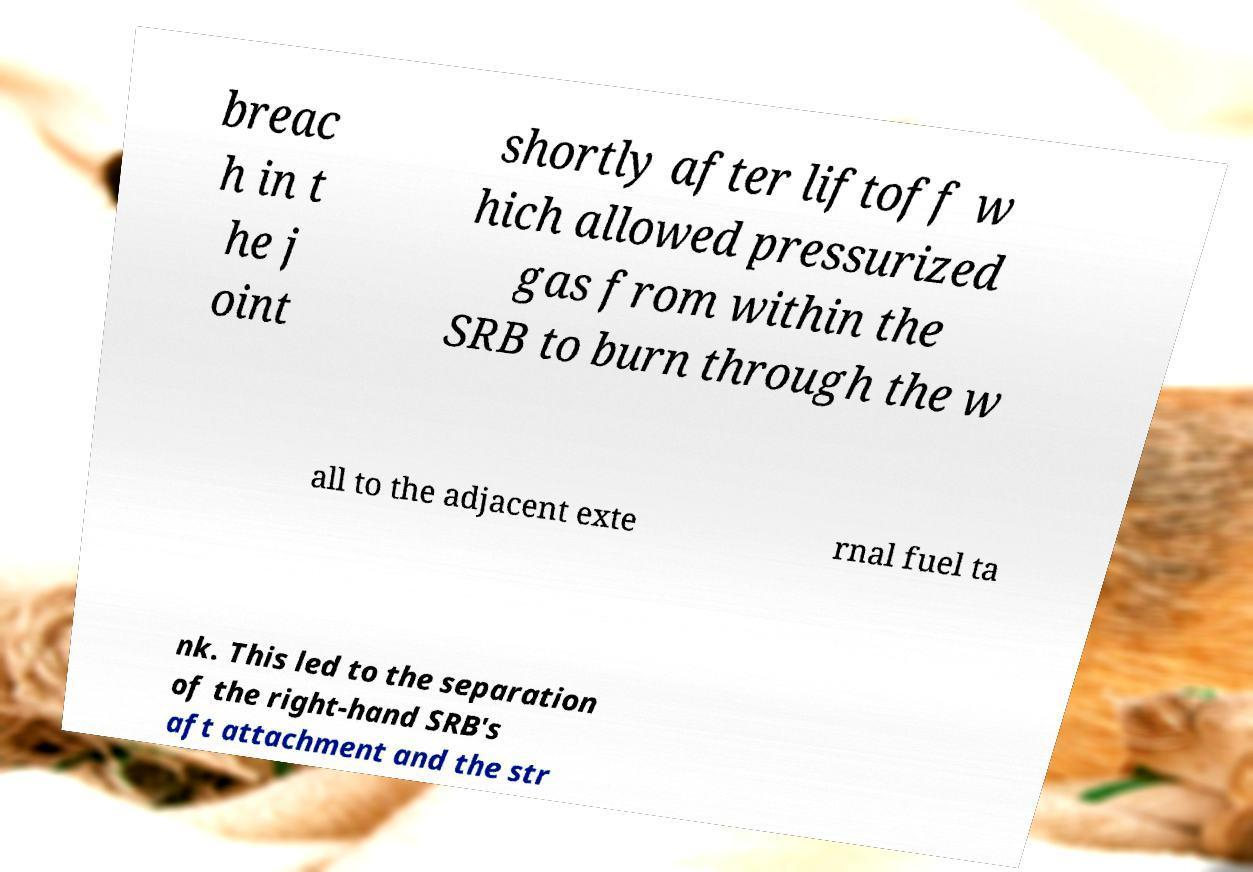For documentation purposes, I need the text within this image transcribed. Could you provide that? breac h in t he j oint shortly after liftoff w hich allowed pressurized gas from within the SRB to burn through the w all to the adjacent exte rnal fuel ta nk. This led to the separation of the right-hand SRB's aft attachment and the str 